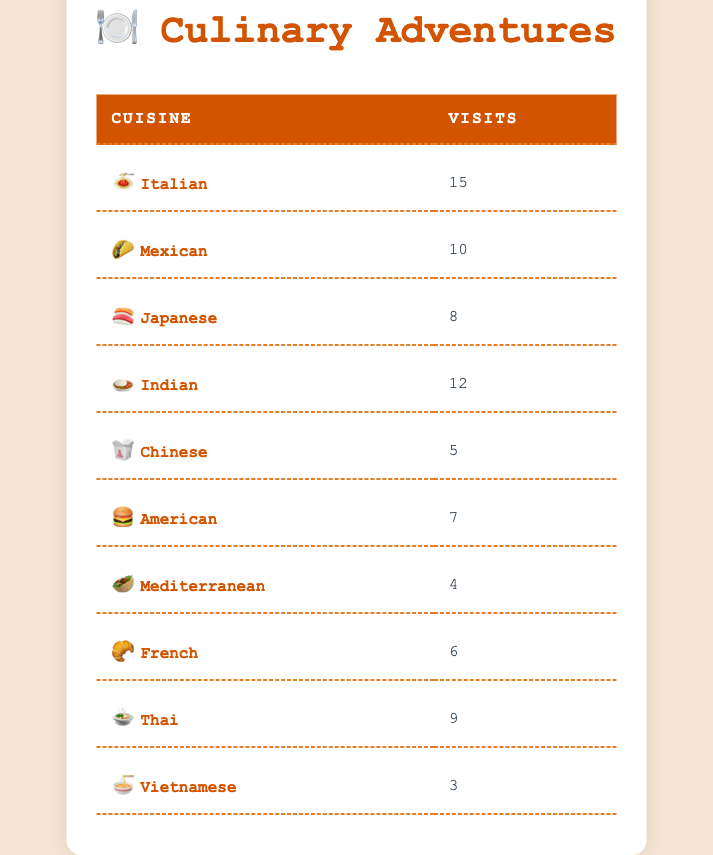What cuisine had the highest frequency of visits? By examining the table, the cuisine with the highest frequency of visits is Italian, with a total of 15 visits noted.
Answer: Italian How many total visits were recorded for all cuisines? The total visits can be calculated by summing the frequency of visits for each cuisine: 15 + 10 + 8 + 12 + 5 + 7 + 4 + 6 + 9 + 3 = 79.
Answer: 79 Is the frequency of visits for French cuisine greater than that of Mediterranean cuisine? In the table, French cuisine has a frequency of 6 visits, while Mediterranean cuisine has 4 visits. Since 6 is greater than 4, the statement is true.
Answer: Yes What is the average number of visits for the cuisines listed? To find the average, sum the total visits which is 79 and divide by the number of cuisines, which is 10: 79/10 = 7.9. Therefore, the average number of visits is 7.9.
Answer: 7.9 Which cuisine has a frequency of visits closest to the average number of visits? The average number of visits is 7.9. The cuisines with frequencies 7 (American) and 8 (Japanese) are closest to the average.
Answer: American and Japanese How many cuisines have a frequency of visits greater than 8? From the table, Italian (15), Mexican (10), and Indian (12) have frequencies greater than 8. That totals to 3 cuisines.
Answer: 3 Which cuisine has the smallest number of visits? By inspecting the table, Vietnamese cuisine has the smallest frequency of visits at 3.
Answer: Vietnamese Is the sum of visits for Italian and Japanese cuisines greater than the sum for Chinese and Mediterranean cuisines? The sum for Italian (15) and Japanese (8) is 23; the sum for Chinese (5) and Mediterranean (4) is 9. Since 23 is greater than 9, the statement is true.
Answer: Yes 